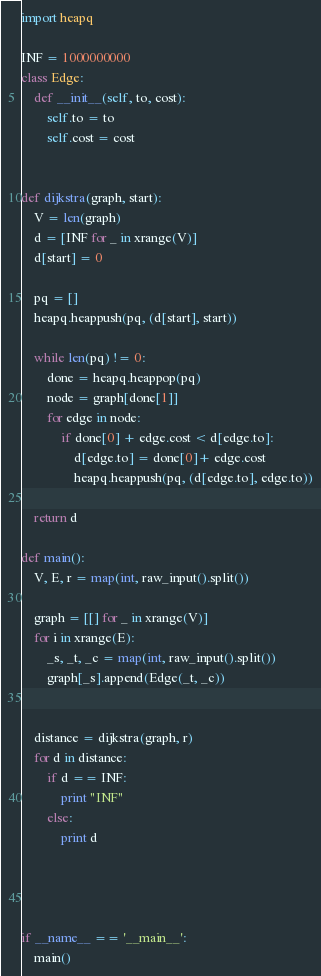<code> <loc_0><loc_0><loc_500><loc_500><_Python_>import heapq

INF = 1000000000
class Edge:
	def __init__(self, to, cost):
		self.to = to
		self.cost = cost


def dijkstra(graph, start):
	V = len(graph)
	d = [INF for _ in xrange(V)]
	d[start] = 0

	pq = []
	heapq.heappush(pq, (d[start], start))

	while len(pq) != 0:
		done = heapq.heappop(pq)
		node = graph[done[1]]
		for edge in node:
			if done[0] + edge.cost < d[edge.to]:
				d[edge.to] = done[0]+ edge.cost
				heapq.heappush(pq, (d[edge.to], edge.to))

	return d

def main():
	V, E, r = map(int, raw_input().split())

	graph = [[] for _ in xrange(V)]
	for i in xrange(E):
		_s, _t, _c = map(int, raw_input().split())
		graph[_s].append(Edge(_t, _c))


	distance = dijkstra(graph, r)
	for d in distance:
		if d == INF:
			print "INF"
		else:
			print d




if __name__ == '__main__':
	main()</code> 